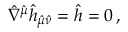<formula> <loc_0><loc_0><loc_500><loc_500>\hat { \nabla } ^ { \hat { \mu } } \hat { h } _ { \hat { \mu } \hat { \nu } } = \hat { h } = 0 \, ,</formula> 